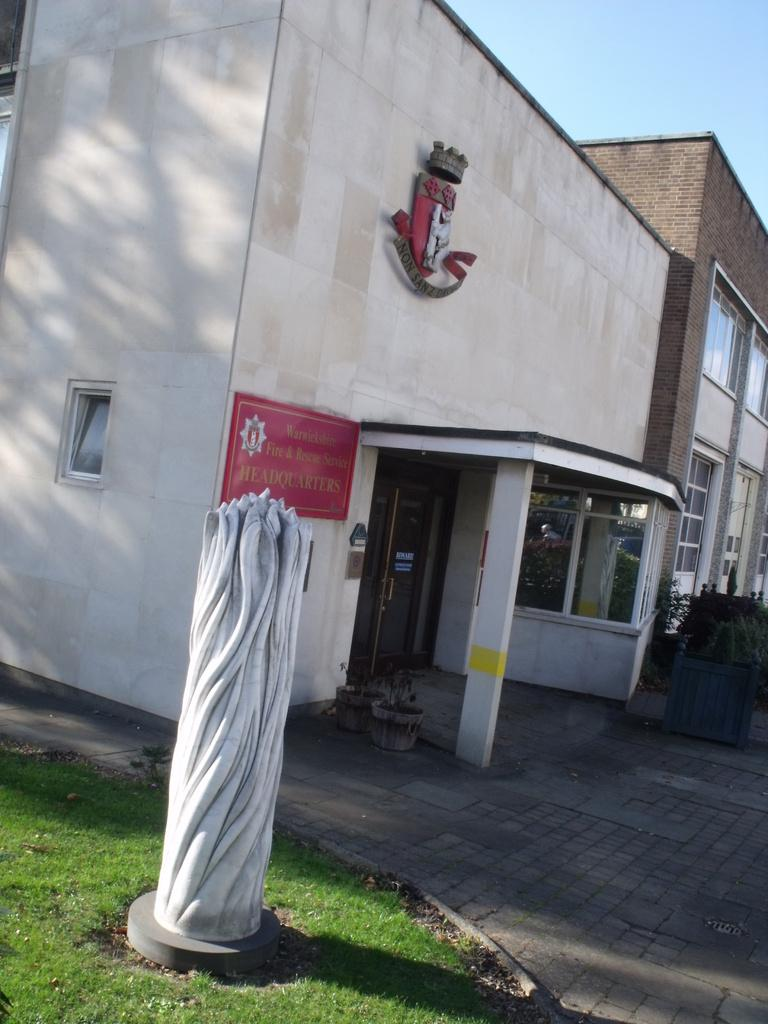What type of structures can be seen in the image? There are buildings in the image. What is hanging or displayed in the image? There is a banner in the image. What type of vegetation is present in the image? There are plants and grass visible in the image. What type of containers are present in the image? There are pots in the image. What part of the natural environment is visible in the image? The sky is visible in the image. Can you tell me how much oil is stored in the pots in the image? There is no oil present in the image; the pots contain plants. What advice might the grandmother in the image give to the person looking at the banner? There is no grandmother present in the image, so it is not possible to answer that question. 